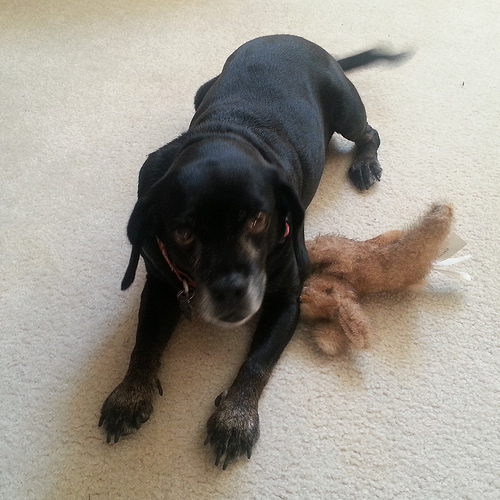<image>
Can you confirm if the toy is under the dog? Yes. The toy is positioned underneath the dog, with the dog above it in the vertical space. Where is the stuffed rabbit in relation to the dog? Is it under the dog? Yes. The stuffed rabbit is positioned underneath the dog, with the dog above it in the vertical space. Is the dog above the bunny? Yes. The dog is positioned above the bunny in the vertical space, higher up in the scene. 